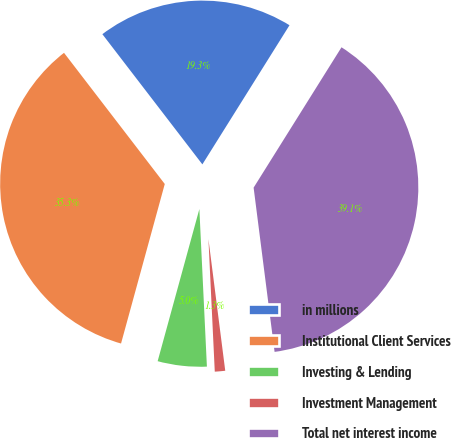Convert chart to OTSL. <chart><loc_0><loc_0><loc_500><loc_500><pie_chart><fcel>in millions<fcel>Institutional Client Services<fcel>Investing & Lending<fcel>Investment Management<fcel>Total net interest income<nl><fcel>19.33%<fcel>35.32%<fcel>5.02%<fcel>1.26%<fcel>39.08%<nl></chart> 